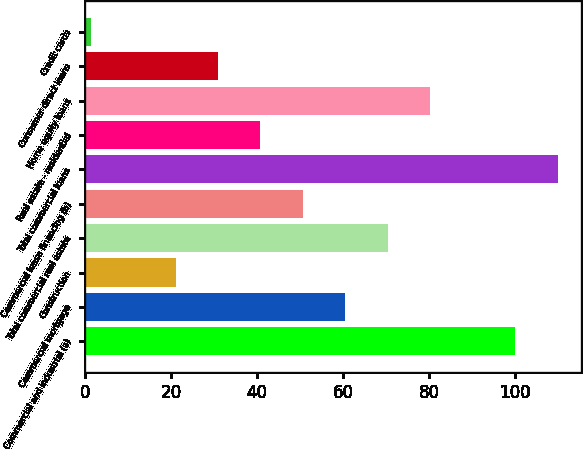<chart> <loc_0><loc_0><loc_500><loc_500><bar_chart><fcel>Commercial and industrial (a)<fcel>Commercial mortgage<fcel>Construction<fcel>Total commercial real estate<fcel>Commercial lease financing (b)<fcel>Total commercial loans<fcel>Real estate - residential<fcel>Home equity loans<fcel>Consumer direct loans<fcel>Credit cards<nl><fcel>100<fcel>60.52<fcel>21.04<fcel>70.39<fcel>50.65<fcel>109.87<fcel>40.78<fcel>80.26<fcel>30.91<fcel>1.3<nl></chart> 